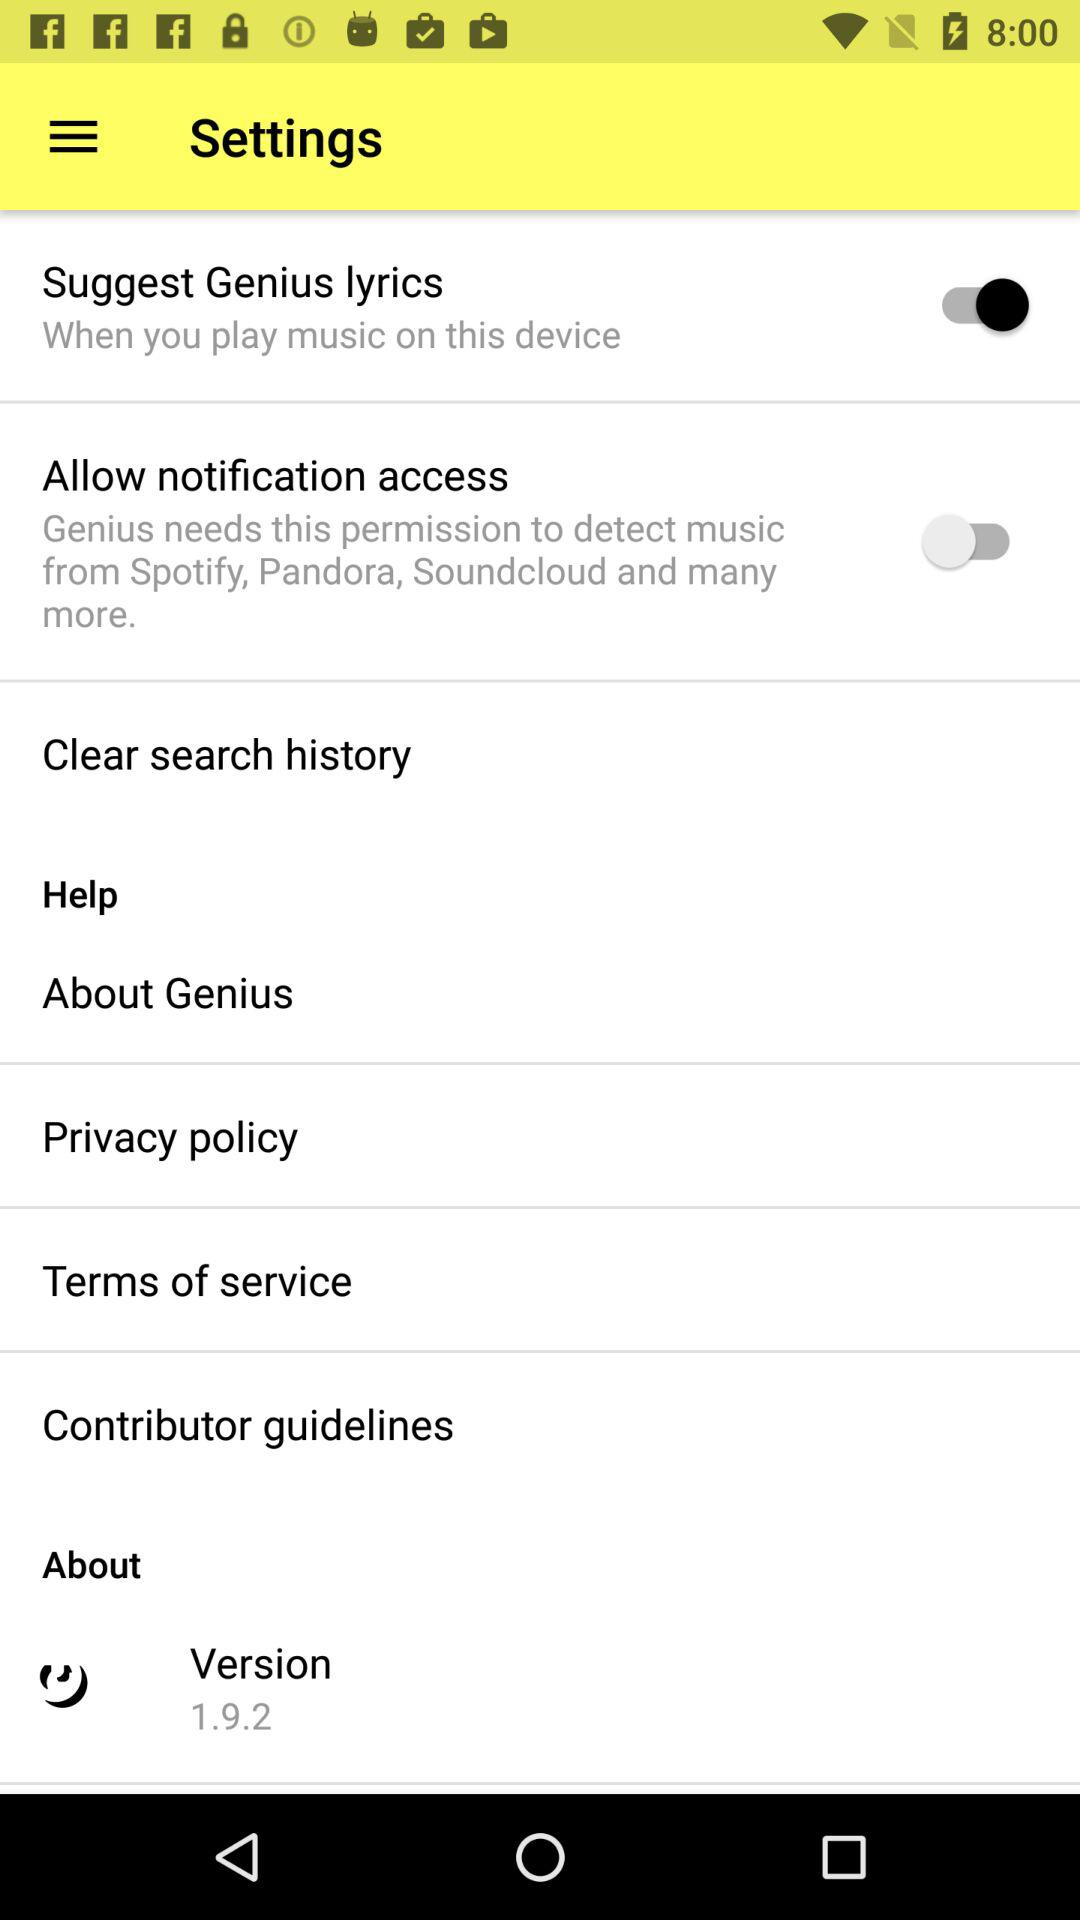What is the version of the application? The version of the application is 1.9.2. 